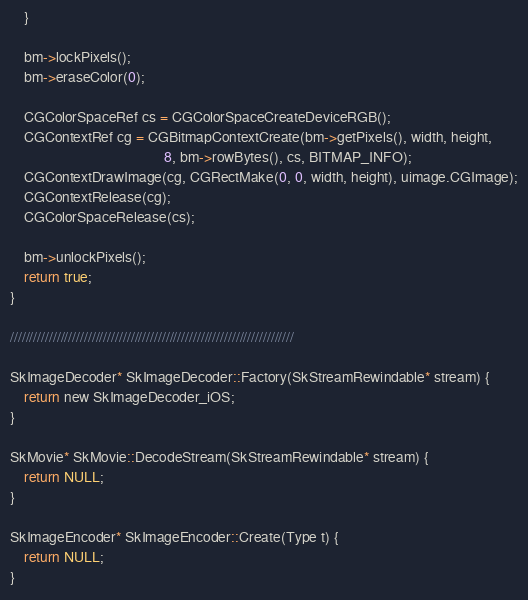Convert code to text. <code><loc_0><loc_0><loc_500><loc_500><_ObjectiveC_>    }
    
    bm->lockPixels();
    bm->eraseColor(0);
    
    CGColorSpaceRef cs = CGColorSpaceCreateDeviceRGB();
    CGContextRef cg = CGBitmapContextCreate(bm->getPixels(), width, height,
                                            8, bm->rowBytes(), cs, BITMAP_INFO);
    CGContextDrawImage(cg, CGRectMake(0, 0, width, height), uimage.CGImage);
    CGContextRelease(cg);
    CGColorSpaceRelease(cs);
    
    bm->unlockPixels();
    return true;
}

/////////////////////////////////////////////////////////////////////////

SkImageDecoder* SkImageDecoder::Factory(SkStreamRewindable* stream) {
    return new SkImageDecoder_iOS;
}

SkMovie* SkMovie::DecodeStream(SkStreamRewindable* stream) {
    return NULL;
}

SkImageEncoder* SkImageEncoder::Create(Type t) {
    return NULL;
}

</code> 